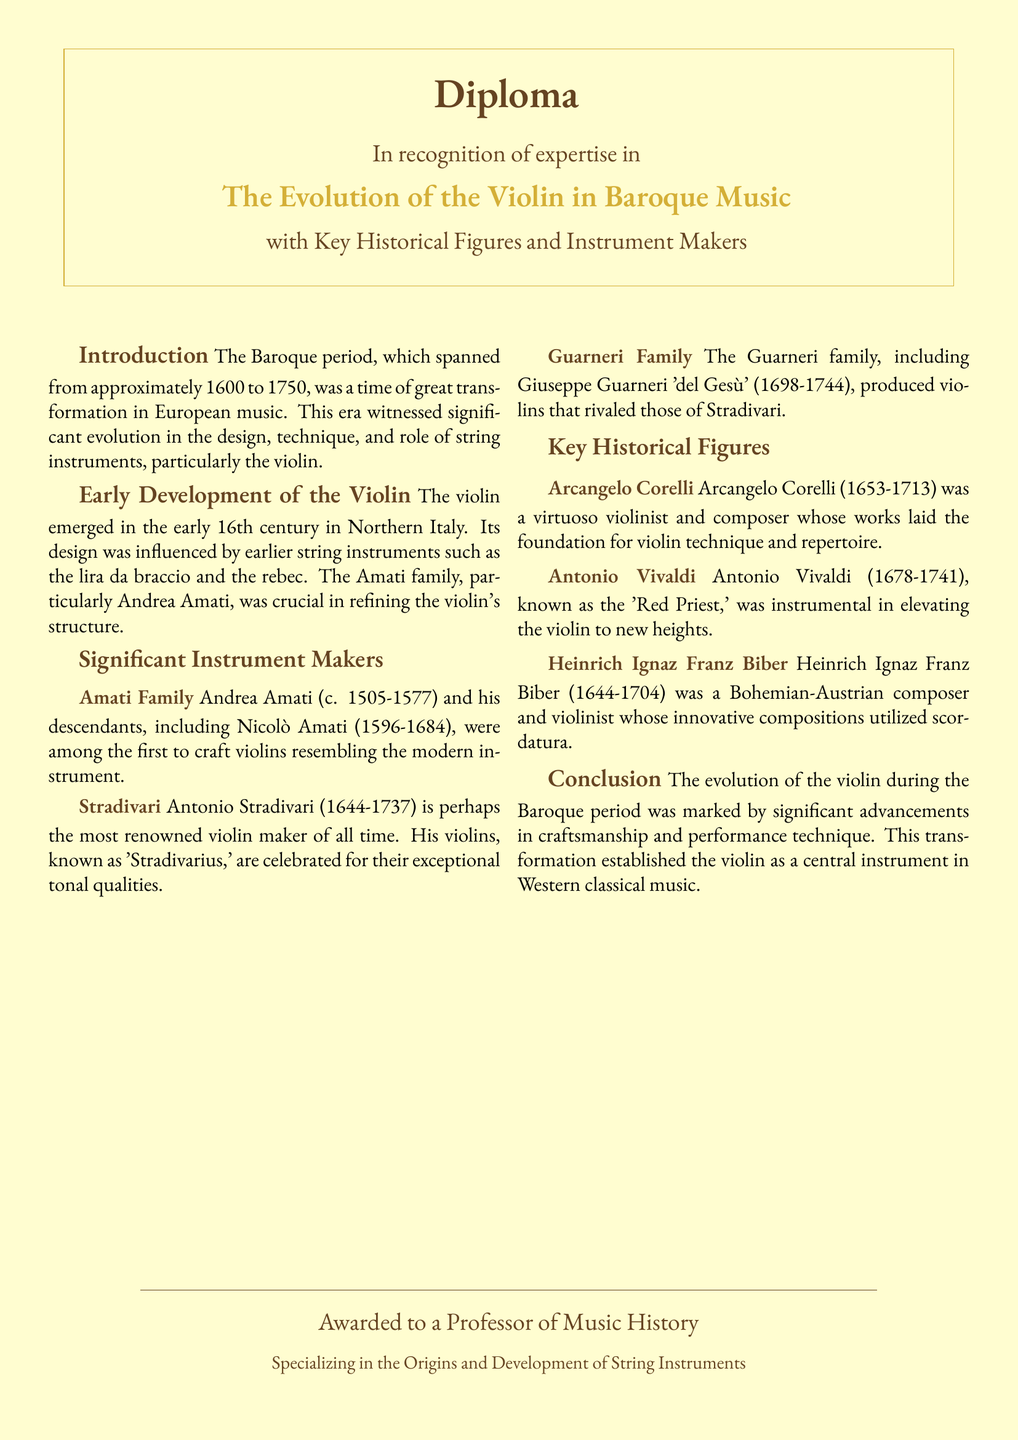What is the title of the diploma? The title of the diploma is prominently displayed at the top of the document, indicating the focus on a specific subject area.
Answer: The Evolution of the Violin in Baroque Music Who is considered the most renowned violin maker? The document mentions a specific figure as the most renowned violin maker, highlighting his legacy and contributions to the craft.
Answer: Antonio Stradivari What years did the Baroque period span? The document defines the time frame of the Baroque period, which is critical for understanding the context and significance of the musical developments during this era.
Answer: 1600 to 1750 Which violin maker's violins are celebrated for their exceptional tonal qualities? The text specifically attributes exceptional tonal qualities to violins made by a particular individual, underscoring his importance in the history of violin making.
Answer: Antonio Stradivari Who was known as the 'Red Priest'? This question references a nickname associated with a historical figure in the context of Baroque music, which is explained in the document.
Answer: Antonio Vivaldi What innovative technique did Heinrich Ignaz Franz Biber utilize in his compositions? The document describes a specific technique associated with a key historical figure's composition style, indicating its relevance in the evolution of violin music.
Answer: Scordatura Which family was crucial in refining the violin's structure? The document highlights a specific family known for their contributions to the development of the violin, illustrating their importance in music history.
Answer: Amati Family What role did Arcangelo Corelli play in Baroque music? The document refers to a significant historical figure and his contributions to violin technique and repertoire, essential for understanding the instrument's evolution.
Answer: Virtuoso violinist and composer What is the central theme of the diploma document? The overarching theme is referred to in various sections and summarizes the focus of the document's content.
Answer: The evolution of the violin during the Baroque period 